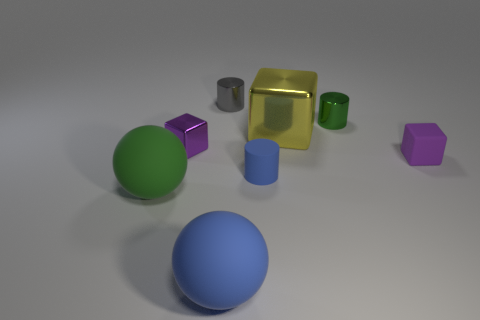What number of matte objects are small blue things or purple objects?
Give a very brief answer. 2. There is another metallic object that is the same shape as the tiny gray thing; what size is it?
Provide a succinct answer. Small. Is there anything else that has the same size as the purple shiny object?
Ensure brevity in your answer.  Yes. There is a purple matte block; is its size the same as the metal thing to the right of the large yellow block?
Give a very brief answer. Yes. There is a tiny purple thing left of the small blue thing; what shape is it?
Your answer should be compact. Cube. There is a rubber object in front of the large green matte thing to the left of the yellow metal block; what color is it?
Your answer should be compact. Blue. What is the color of the other metal object that is the same shape as the tiny gray thing?
Ensure brevity in your answer.  Green. How many big rubber spheres are the same color as the rubber cylinder?
Ensure brevity in your answer.  1. Do the large metallic thing and the small rubber object that is on the left side of the big shiny object have the same color?
Keep it short and to the point. No. What shape is the large object that is left of the small gray thing and to the right of the tiny purple metal block?
Offer a terse response. Sphere. 